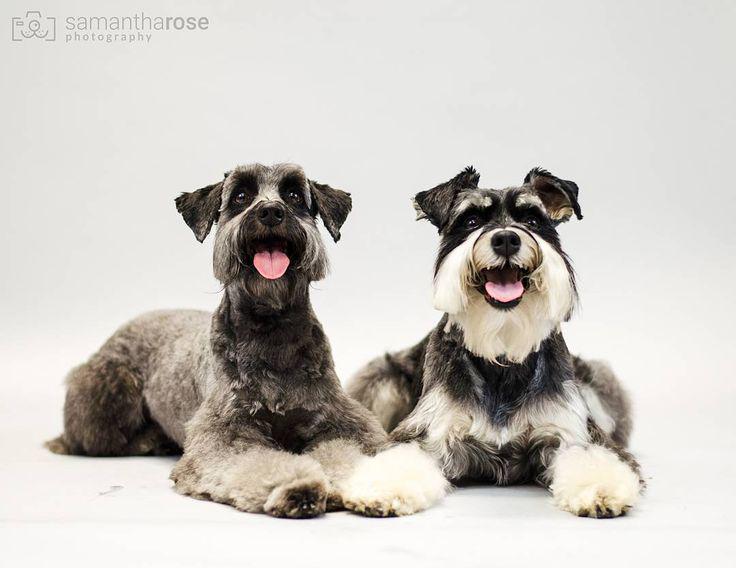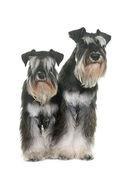The first image is the image on the left, the second image is the image on the right. Given the left and right images, does the statement "There are two dogs in each image." hold true? Answer yes or no. Yes. The first image is the image on the left, the second image is the image on the right. Considering the images on both sides, is "A total of two schnauzer dogs are shown, including one reclining with extended front paws." valid? Answer yes or no. No. 